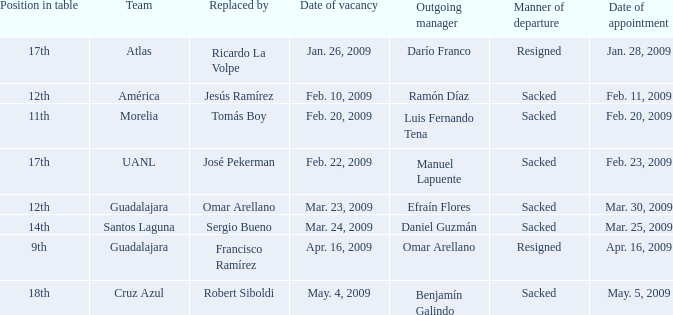What is Manner of Departure, when Outgoing Manager is "Luis Fernando Tena"? Sacked. 